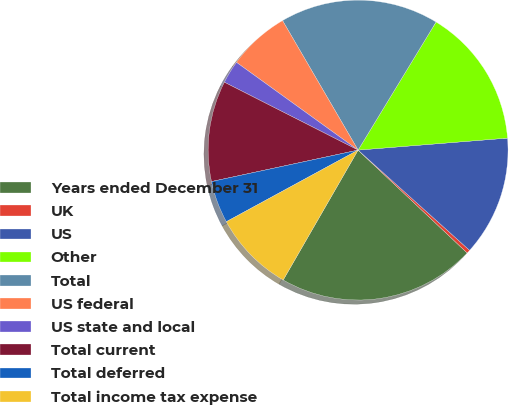Convert chart. <chart><loc_0><loc_0><loc_500><loc_500><pie_chart><fcel>Years ended December 31<fcel>UK<fcel>US<fcel>Other<fcel>Total<fcel>US federal<fcel>US state and local<fcel>Total current<fcel>Total deferred<fcel>Total income tax expense<nl><fcel>21.29%<fcel>0.38%<fcel>12.93%<fcel>15.02%<fcel>17.11%<fcel>6.65%<fcel>2.47%<fcel>10.84%<fcel>4.56%<fcel>8.75%<nl></chart> 